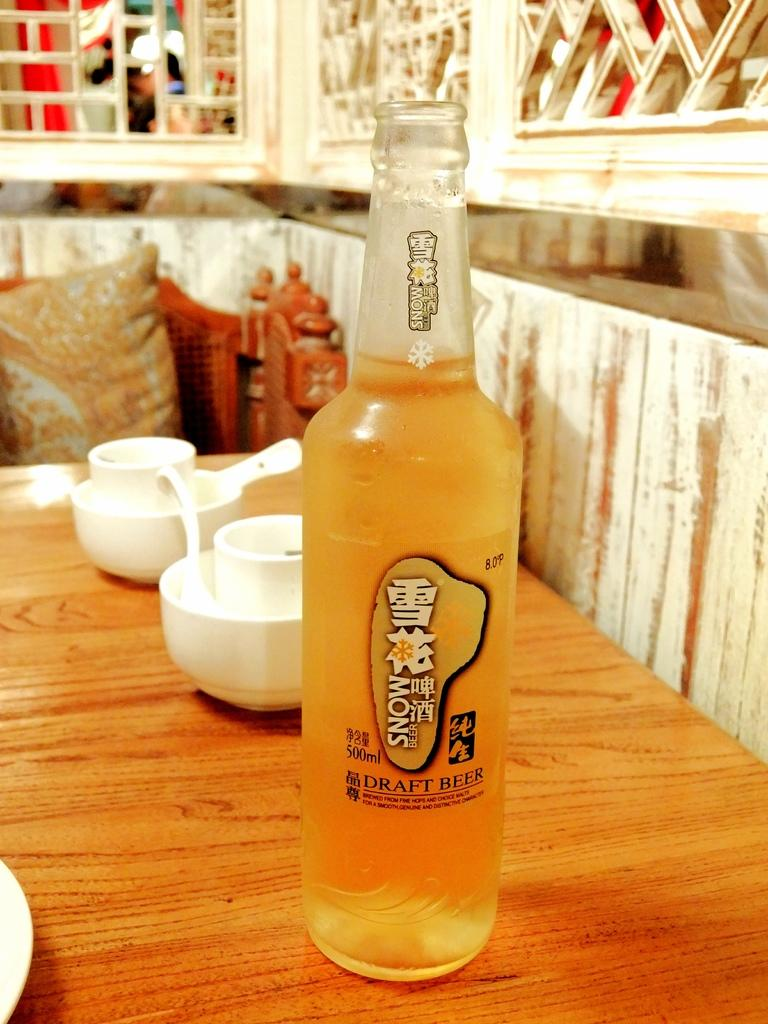What type of container is present in the image? There is a bottle in the image. How many cups are visible in the image? There are two cups in the image. What type of furniture is in the image, and what is on it? There is a chair in the image, and it has a cushion on it. What type of tree is growing in the middle of the cushion on the chair? There is no tree present in the image, and the cushion on the chair is not large enough to accommodate a tree. 